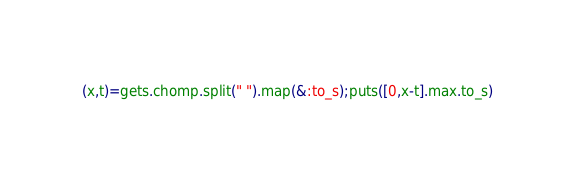Convert code to text. <code><loc_0><loc_0><loc_500><loc_500><_Ruby_>(x,t)=gets.chomp.split(" ").map(&:to_s);puts([0,x-t].max.to_s)</code> 